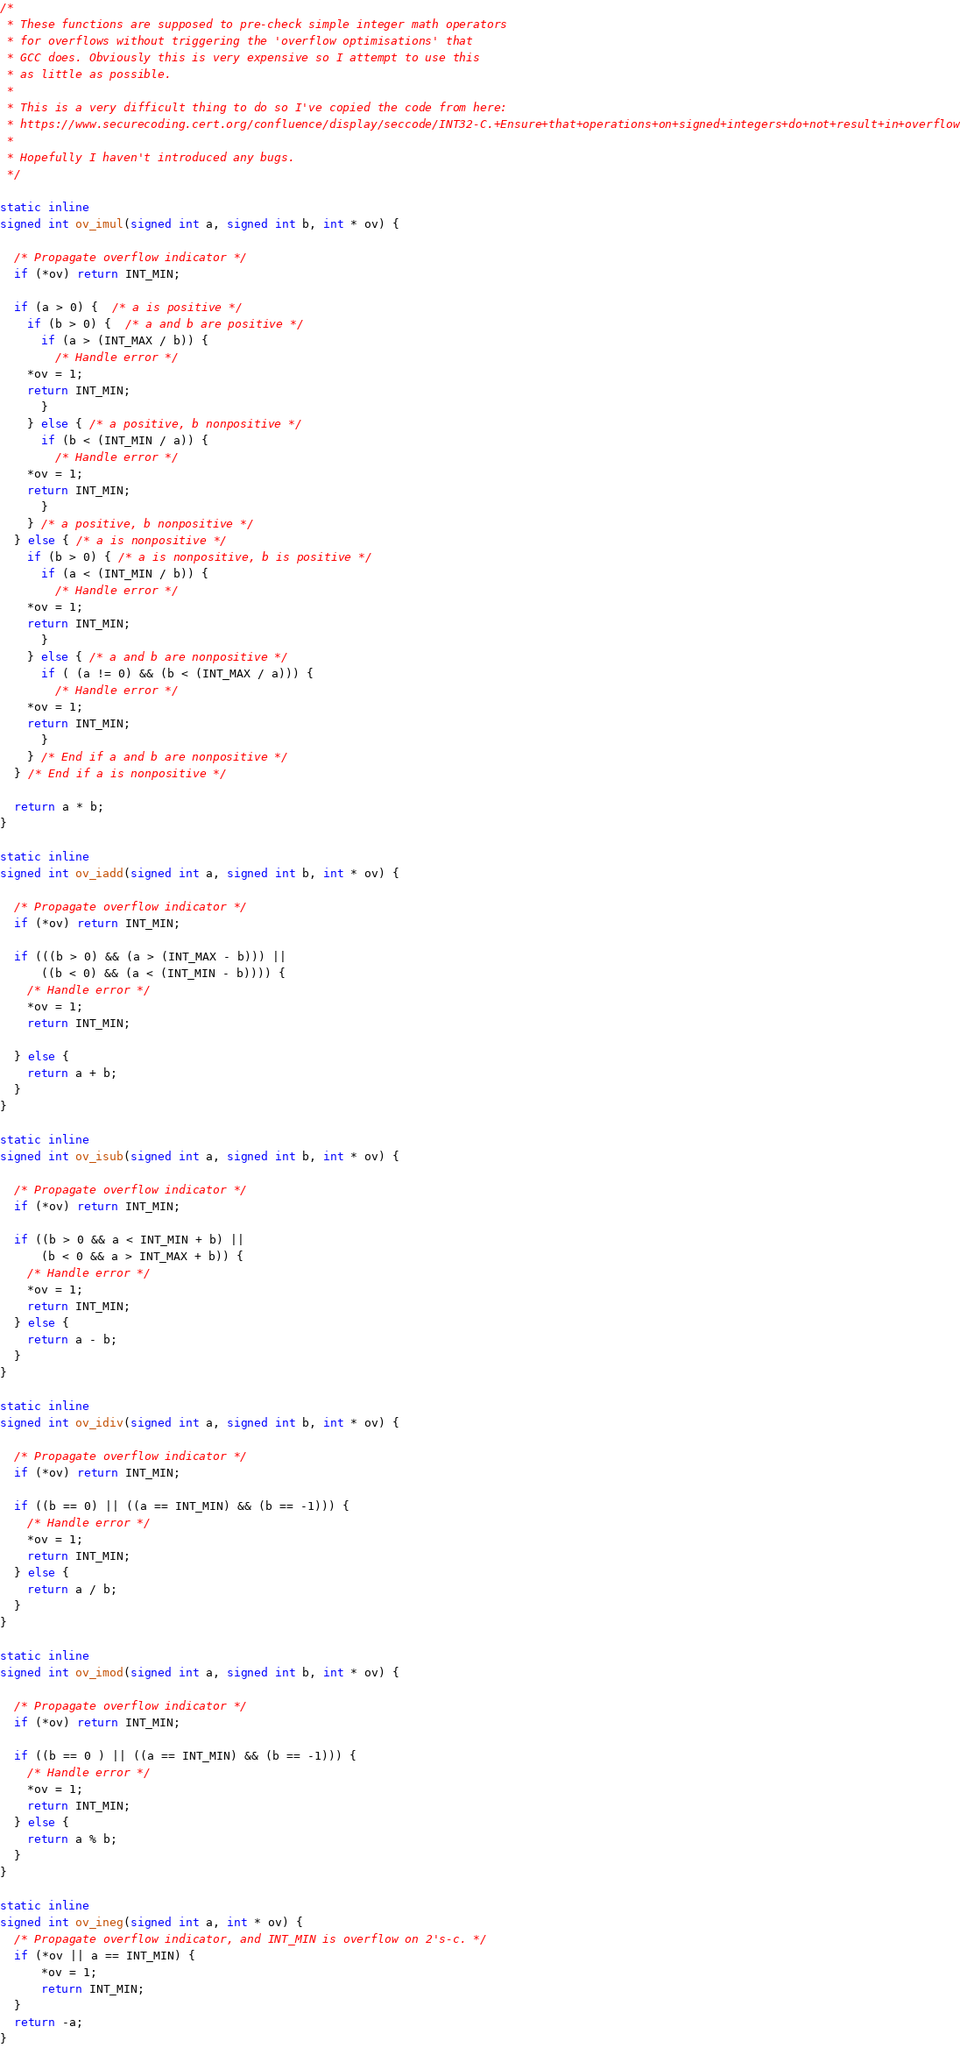Convert code to text. <code><loc_0><loc_0><loc_500><loc_500><_C_>/*
 * These functions are supposed to pre-check simple integer math operators
 * for overflows without triggering the 'overflow optimisations' that
 * GCC does. Obviously this is very expensive so I attempt to use this
 * as little as possible.
 *
 * This is a very difficult thing to do so I've copied the code from here:
 * https://www.securecoding.cert.org/confluence/display/seccode/INT32-C.+Ensure+that+operations+on+signed+integers+do+not+result+in+overflow
 *
 * Hopefully I haven't introduced any bugs.
 */

static inline
signed int ov_imul(signed int a, signed int b, int * ov) {

  /* Propagate overflow indicator */
  if (*ov) return INT_MIN;

  if (a > 0) {  /* a is positive */
    if (b > 0) {  /* a and b are positive */
      if (a > (INT_MAX / b)) {
        /* Handle error */
	*ov = 1;
	return INT_MIN;
      }
    } else { /* a positive, b nonpositive */
      if (b < (INT_MIN / a)) {
        /* Handle error */
	*ov = 1;
	return INT_MIN;
      }
    } /* a positive, b nonpositive */
  } else { /* a is nonpositive */
    if (b > 0) { /* a is nonpositive, b is positive */
      if (a < (INT_MIN / b)) {
        /* Handle error */
	*ov = 1;
	return INT_MIN;
      }
    } else { /* a and b are nonpositive */
      if ( (a != 0) && (b < (INT_MAX / a))) {
        /* Handle error */
	*ov = 1;
	return INT_MIN;
      }
    } /* End if a and b are nonpositive */
  } /* End if a is nonpositive */

  return a * b;
}

static inline
signed int ov_iadd(signed int a, signed int b, int * ov) {

  /* Propagate overflow indicator */
  if (*ov) return INT_MIN;

  if (((b > 0) && (a > (INT_MAX - b))) ||
      ((b < 0) && (a < (INT_MIN - b)))) {
    /* Handle error */
    *ov = 1;
    return INT_MIN;

  } else {
    return a + b;
  }
}

static inline
signed int ov_isub(signed int a, signed int b, int * ov) {

  /* Propagate overflow indicator */
  if (*ov) return INT_MIN;

  if ((b > 0 && a < INT_MIN + b) ||
      (b < 0 && a > INT_MAX + b)) {
    /* Handle error */
    *ov = 1;
    return INT_MIN;
  } else {
    return a - b;
  }
}

static inline
signed int ov_idiv(signed int a, signed int b, int * ov) {

  /* Propagate overflow indicator */
  if (*ov) return INT_MIN;

  if ((b == 0) || ((a == INT_MIN) && (b == -1))) {
    /* Handle error */
    *ov = 1;
    return INT_MIN;
  } else {
    return a / b;
  }
}

static inline
signed int ov_imod(signed int a, signed int b, int * ov) {

  /* Propagate overflow indicator */
  if (*ov) return INT_MIN;

  if ((b == 0 ) || ((a == INT_MIN) && (b == -1))) {
    /* Handle error */
    *ov = 1;
    return INT_MIN;
  } else {
    return a % b;
  }
}

static inline
signed int ov_ineg(signed int a, int * ov) {
  /* Propagate overflow indicator, and INT_MIN is overflow on 2's-c. */
  if (*ov || a == INT_MIN) {
      *ov = 1;
      return INT_MIN;
  }
  return -a;
}
</code> 